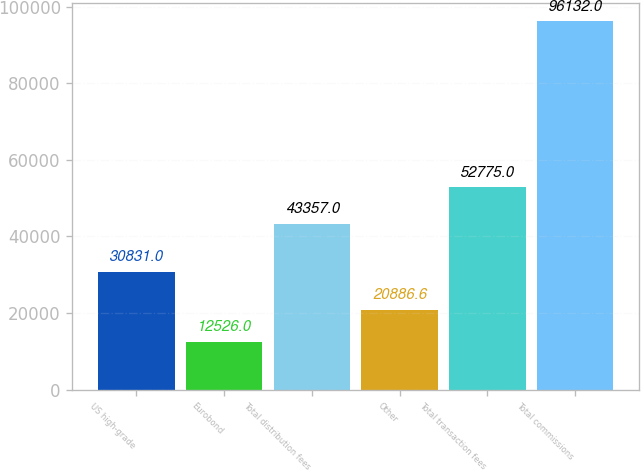Convert chart. <chart><loc_0><loc_0><loc_500><loc_500><bar_chart><fcel>US high-grade<fcel>Eurobond<fcel>Total distribution fees<fcel>Other<fcel>Total transaction fees<fcel>Total commissions<nl><fcel>30831<fcel>12526<fcel>43357<fcel>20886.6<fcel>52775<fcel>96132<nl></chart> 